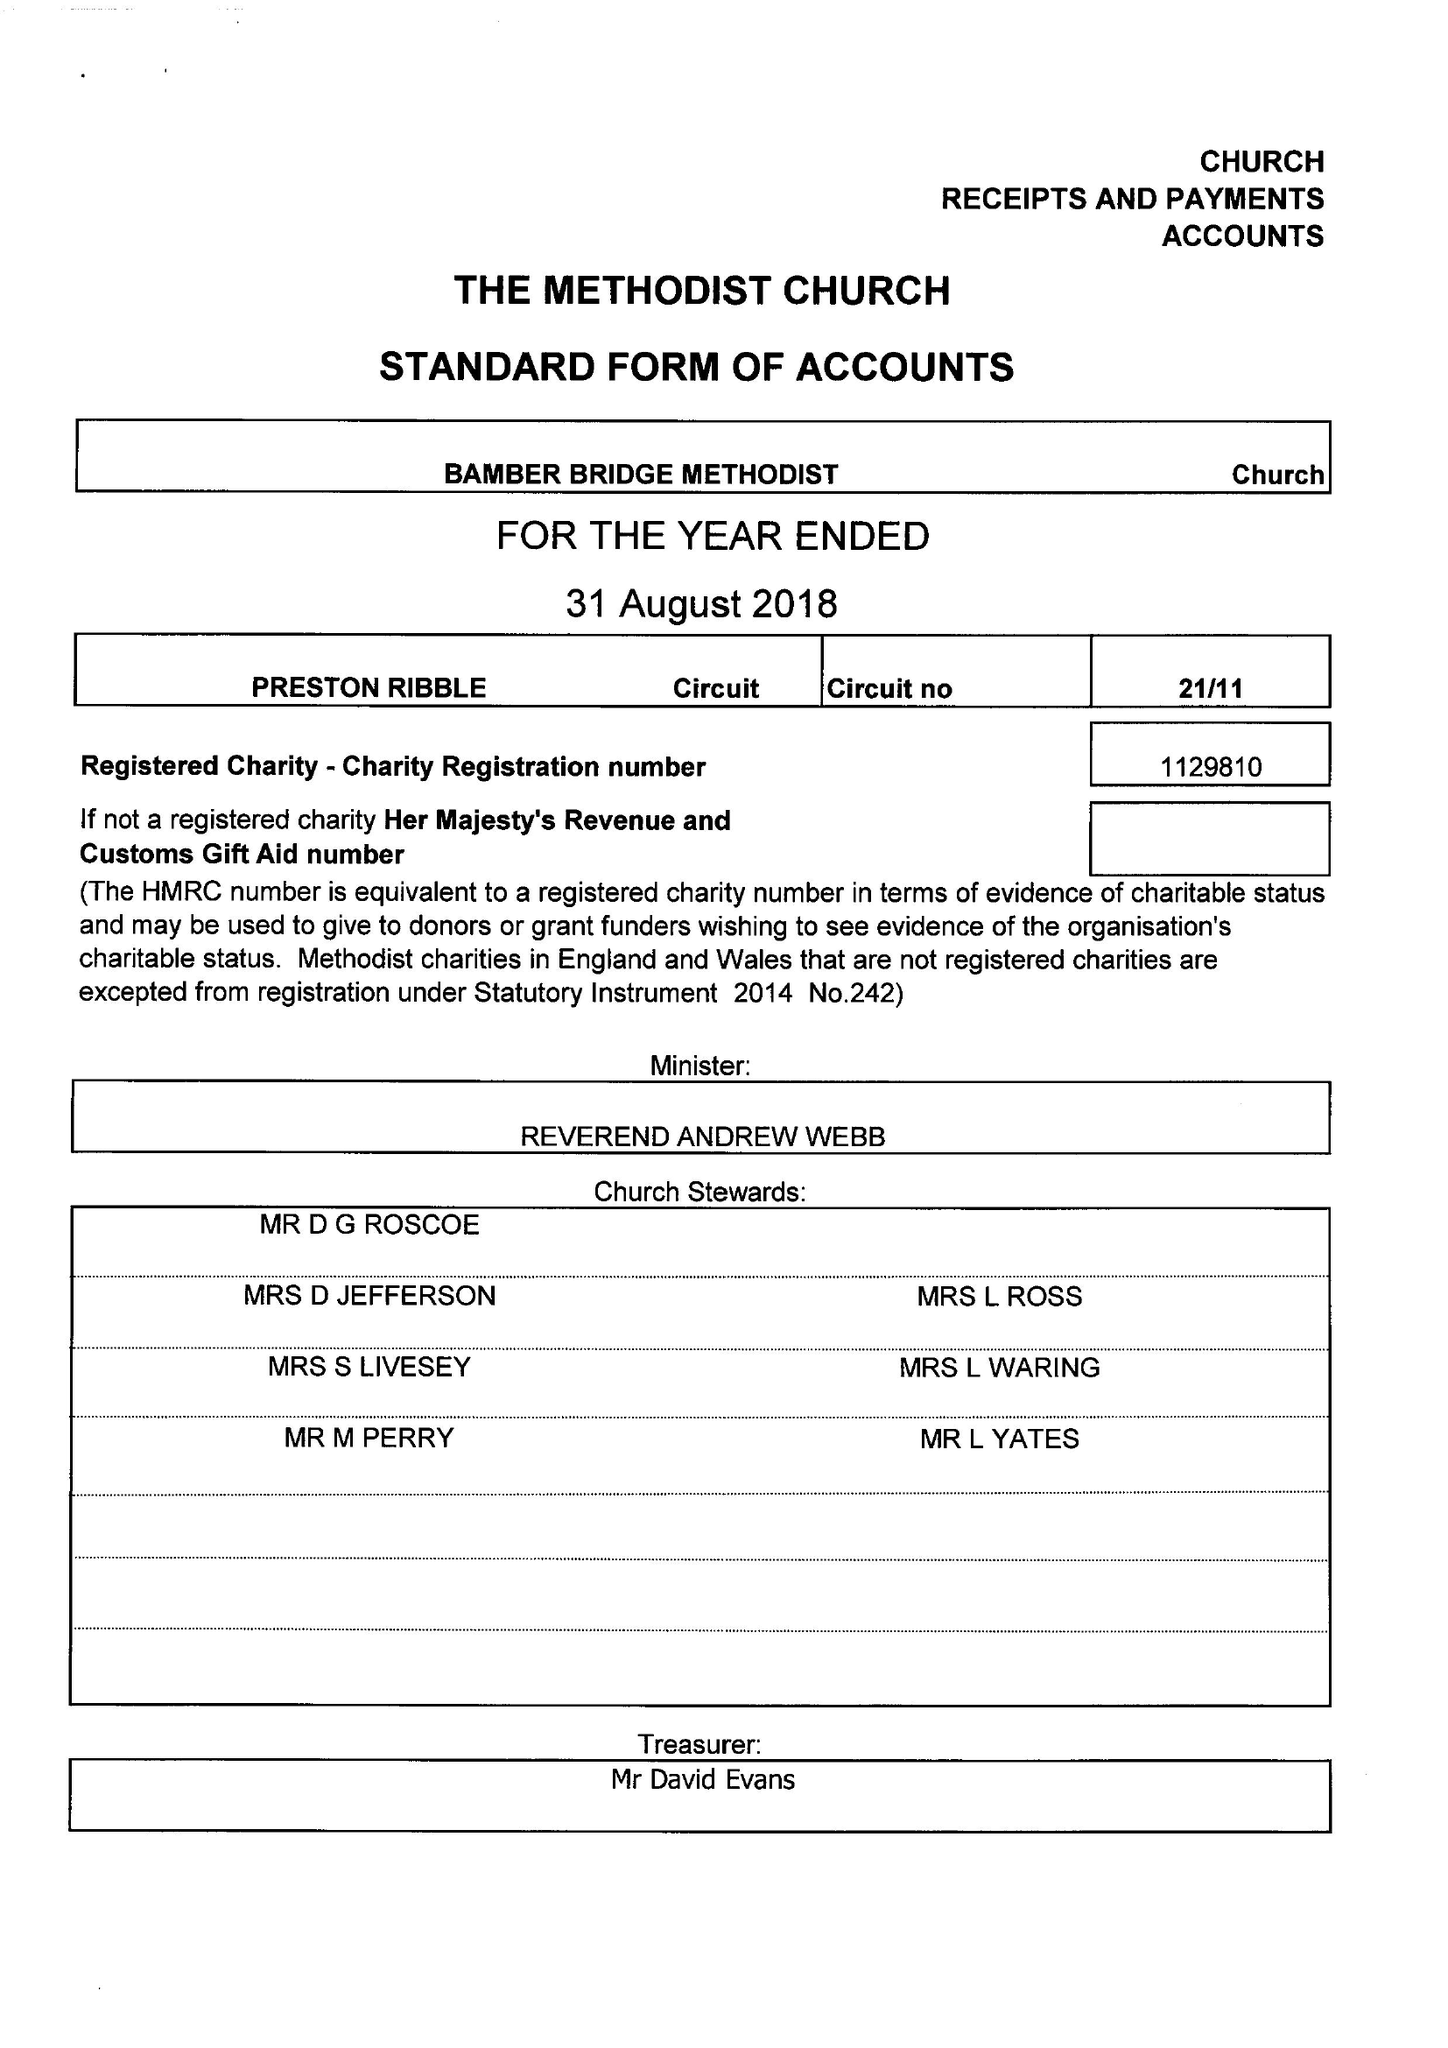What is the value for the charity_number?
Answer the question using a single word or phrase. 1129810 